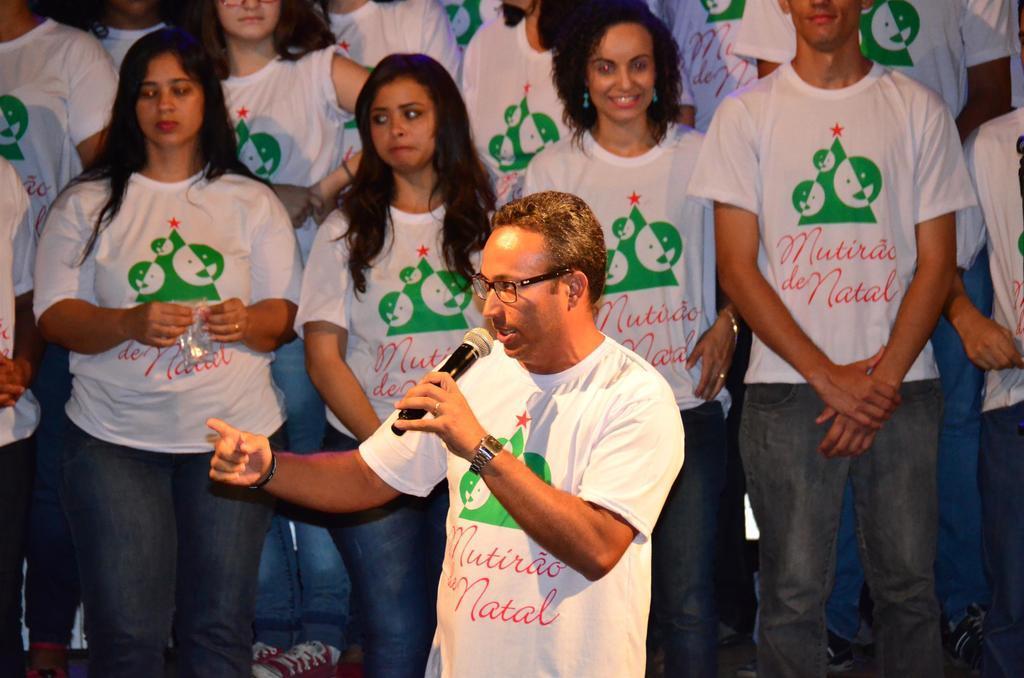How would you summarize this image in a sentence or two? In this image I can see few people are standing and wearing white, red and green color t-shirts. In front one person is standing and holding the mic. 